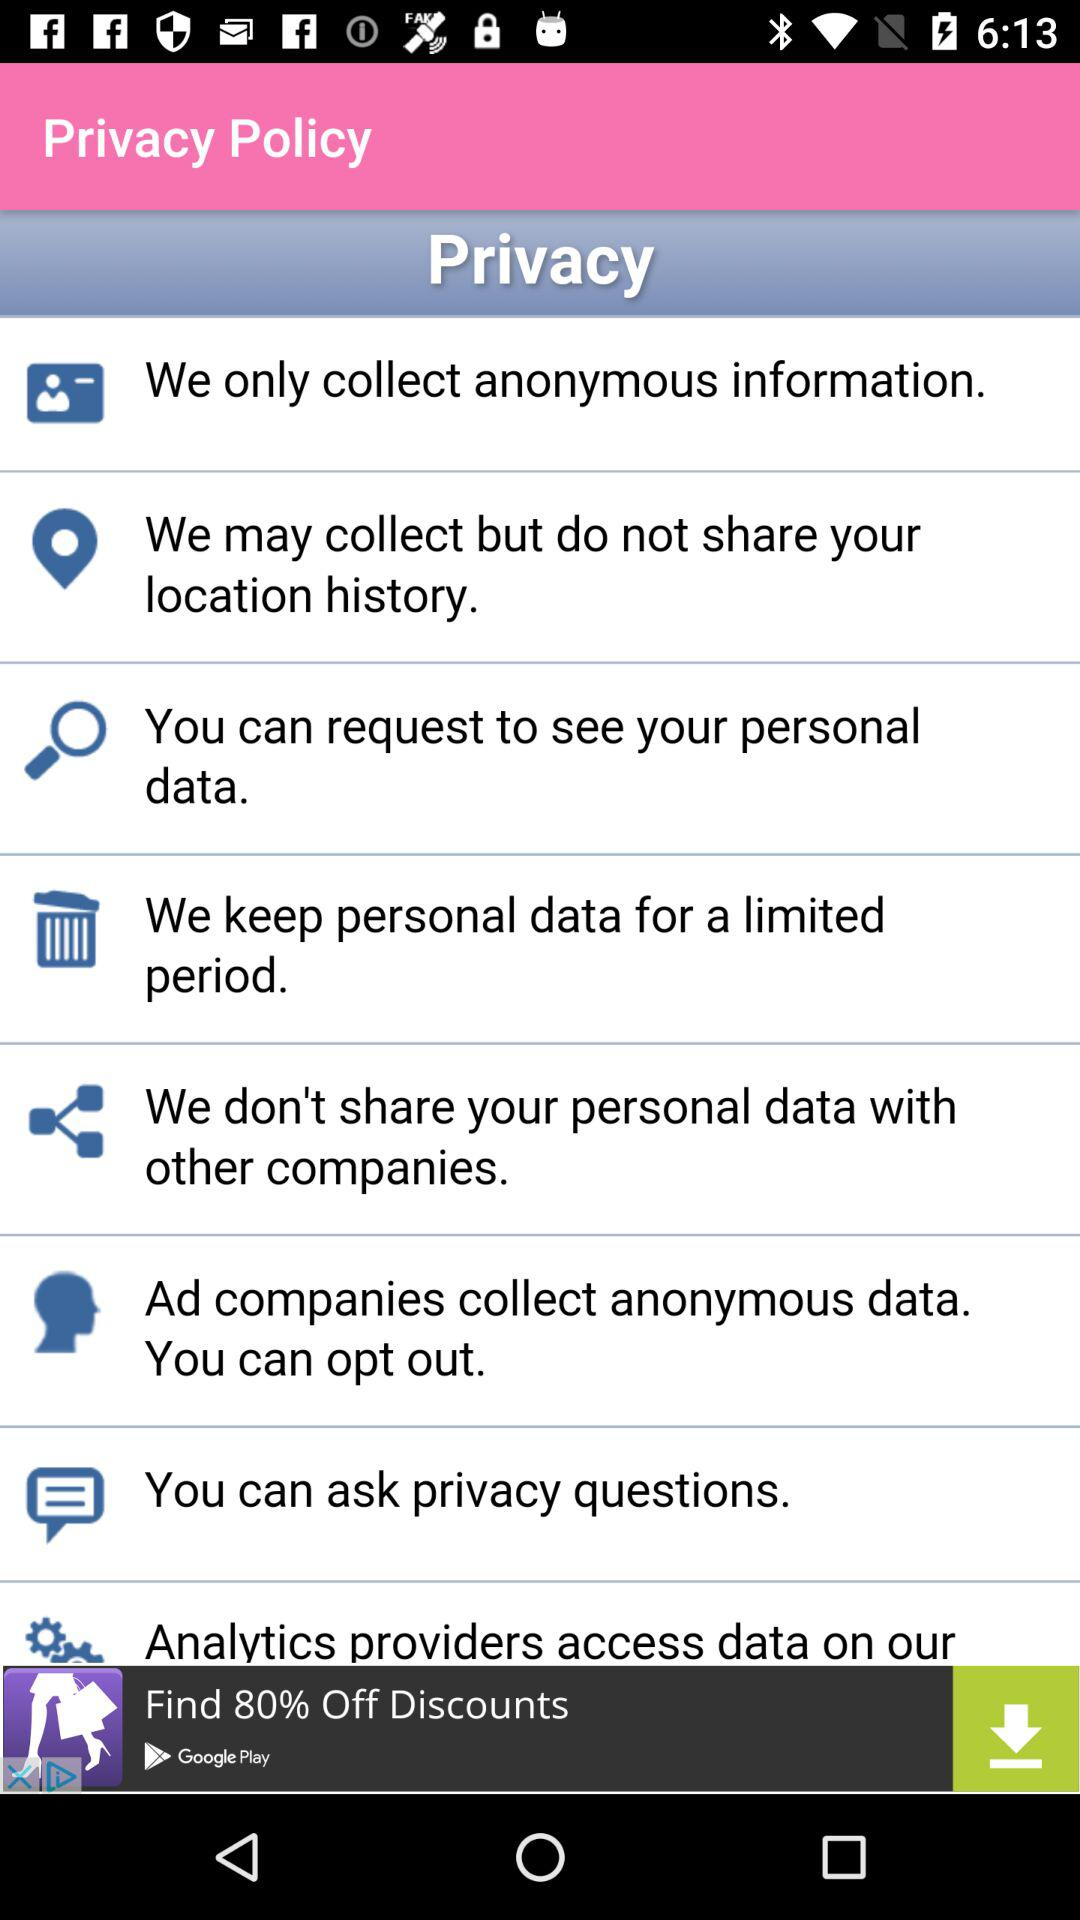What is the name of the application? The name of the application is "Baby Predictor". 